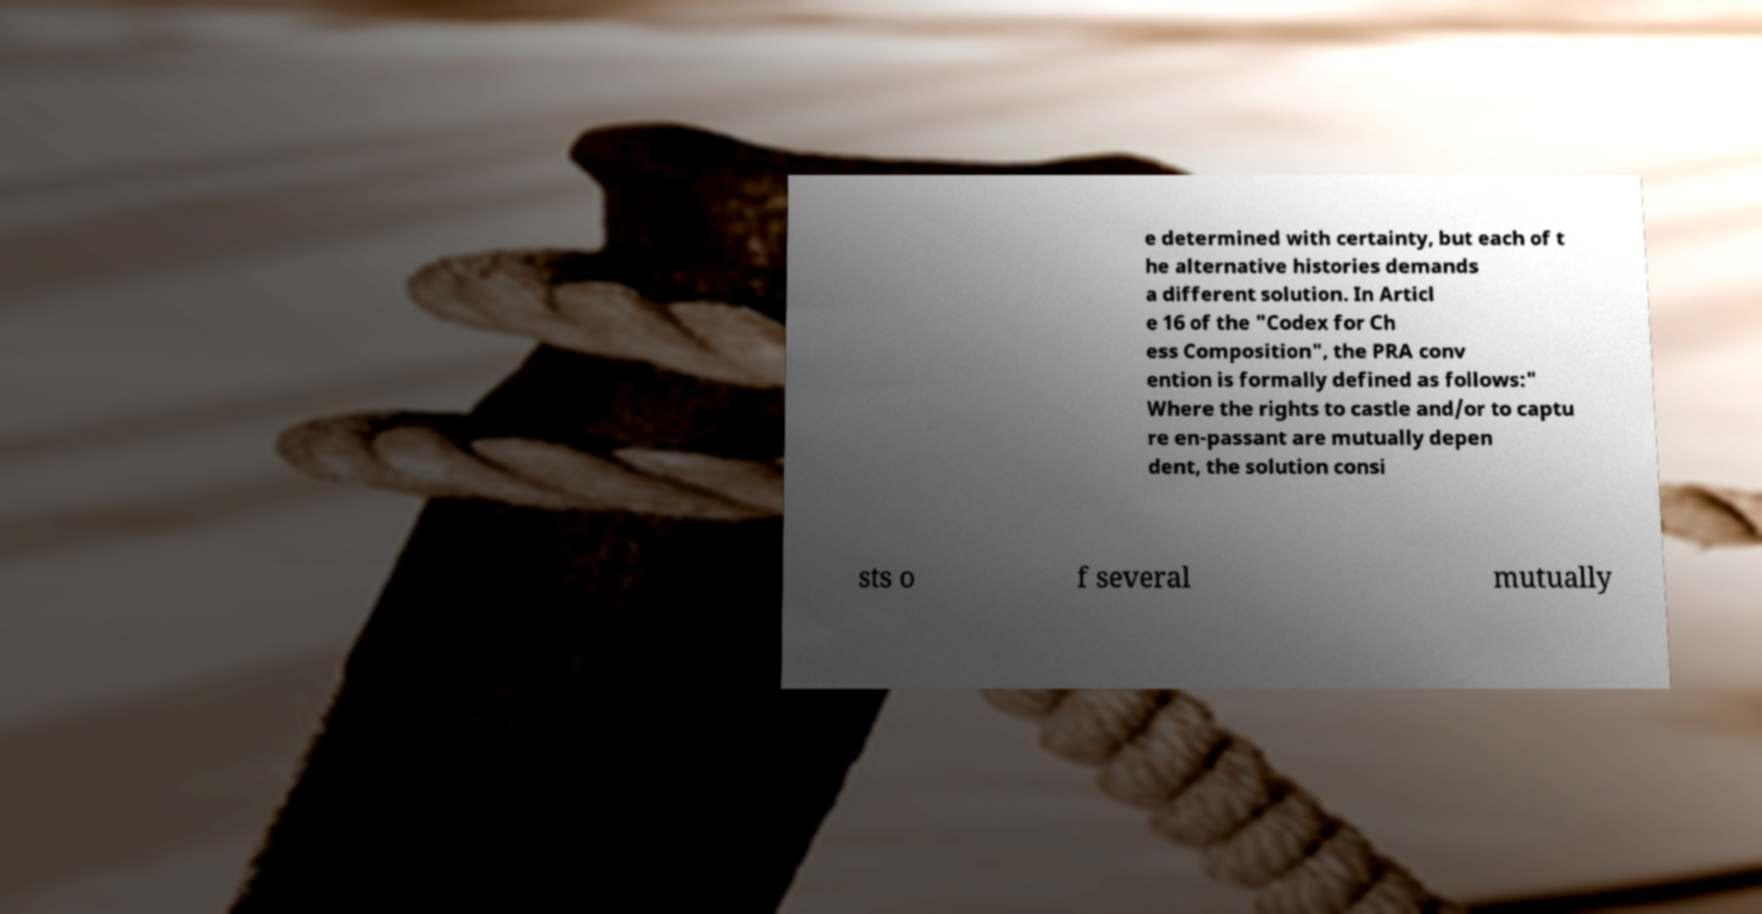For documentation purposes, I need the text within this image transcribed. Could you provide that? e determined with certainty, but each of t he alternative histories demands a different solution. In Articl e 16 of the "Codex for Ch ess Composition", the PRA conv ention is formally defined as follows:" Where the rights to castle and/or to captu re en-passant are mutually depen dent, the solution consi sts o f several mutually 